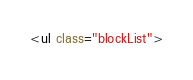<code> <loc_0><loc_0><loc_500><loc_500><_HTML_><ul class="blockList"></code> 